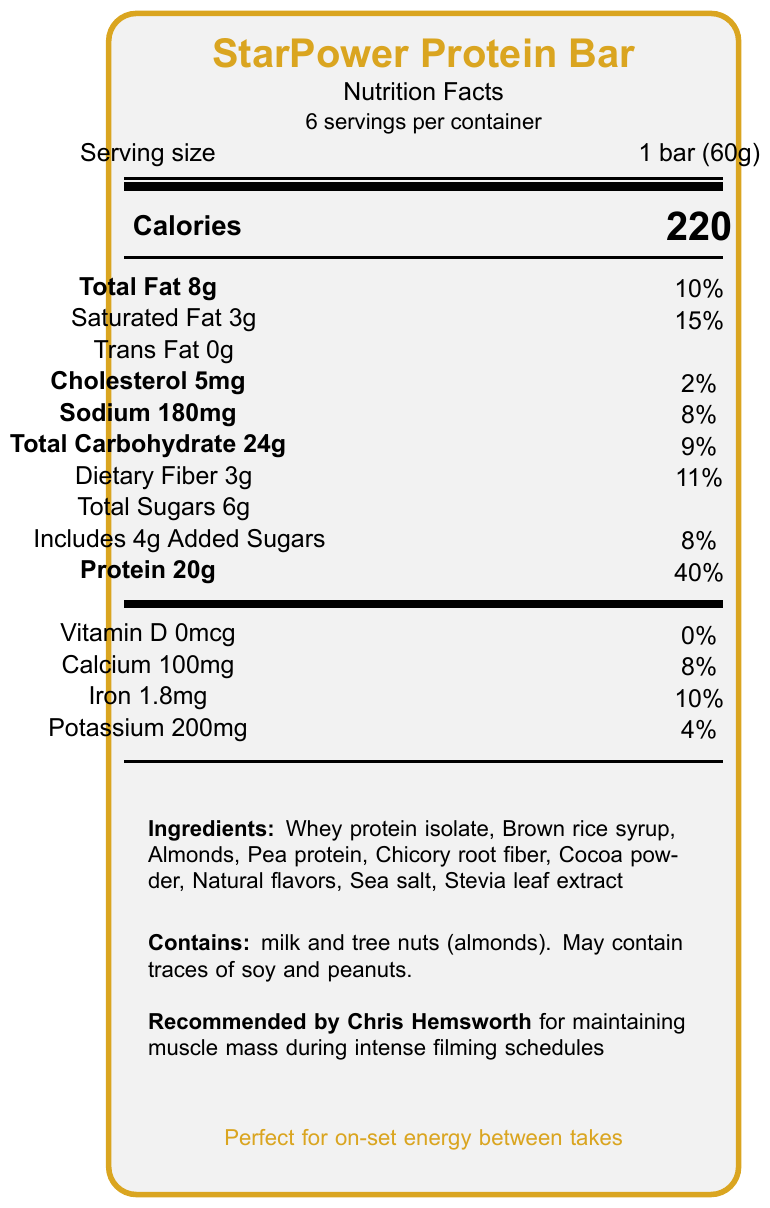what is the protein content per bar? The document states that each StarPower Protein Bar contains 20g of protein.
Answer: 20g how many calories are in one serving? The document specifies that one serving (1 bar) contains 220 calories.
Answer: 220 how much dietary fiber is in each bar? The document indicates that there is 3g of dietary fiber per bar.
Answer: 3g what is the main ingredient in the protein bars? The list of ingredients starts with "Whey protein isolate," indicating it is the main ingredient.
Answer: Whey protein isolate does the protein bar contain any artificial sweeteners? The marketing claims specifically mention "No artificial sweeteners or preservatives."
Answer: No what is the serving size for the StarPower Protein Bar? The serving size is listed as 1 bar (60g).
Answer: 1 bar (60g) how many total carbohydrates are there in one bar? A. 20g B. 24g C. 30g D. 50g The total carbohydrate content is listed as 24g per serving.
Answer: B. 24g which of the following statements is true about the sugar content? A. The bar has no added sugars. B. It has 6g of total sugars, including 4g of added sugars. C. The bar contains 10g of total sugars. The document indicates that the bar contains 6g of total sugars, which includes 4g of added sugars.
Answer: B. It has 6g of total sugars, including 4g of added sugars. is the bar recommended by a celebrity? The document mentions that the bar is recommended by Chris Hemsworth for maintaining muscle mass during intense filming schedules.
Answer: Yes how would you summarize the main nutritional benefits of the StarPower Protein Bar? The document highlights the high-quality protein content, low sugar levels, and high fiber as key benefits. It also features endorsements and marketing aimed at actors needing sustained energy without compromising nutrition goals.
Answer: The StarPower Protein Bar provides a high protein content (20g), is low in sugar, and is a good source of dietary fiber. It is marketed as a nutritious option for actors needing sustained energy on set. how much saturated fat is in each bar? The saturated fat content per bar is listed as 3g.
Answer: 3g what is the daily value percentage of protein provided by one bar? The document specifies that one bar provides 40% of the daily protein value.
Answer: 40% what is the total fat content in grams? The document states that the total fat content is 8g per bar.
Answer: 8g what is the calcium content in each bar? The nutritional facts list the calcium content as 100mg per bar.
Answer: 100mg how many servings are there per container? Each container holds 6 servings, as indicated in the document.
Answer: 6 is the bar suitable for someone with a peanut allergy? The allergen information warns that the bar may contain traces of peanuts, but it does not confirm whether it is suitable for someone with a severe allergy.
Answer: Cannot be determined 